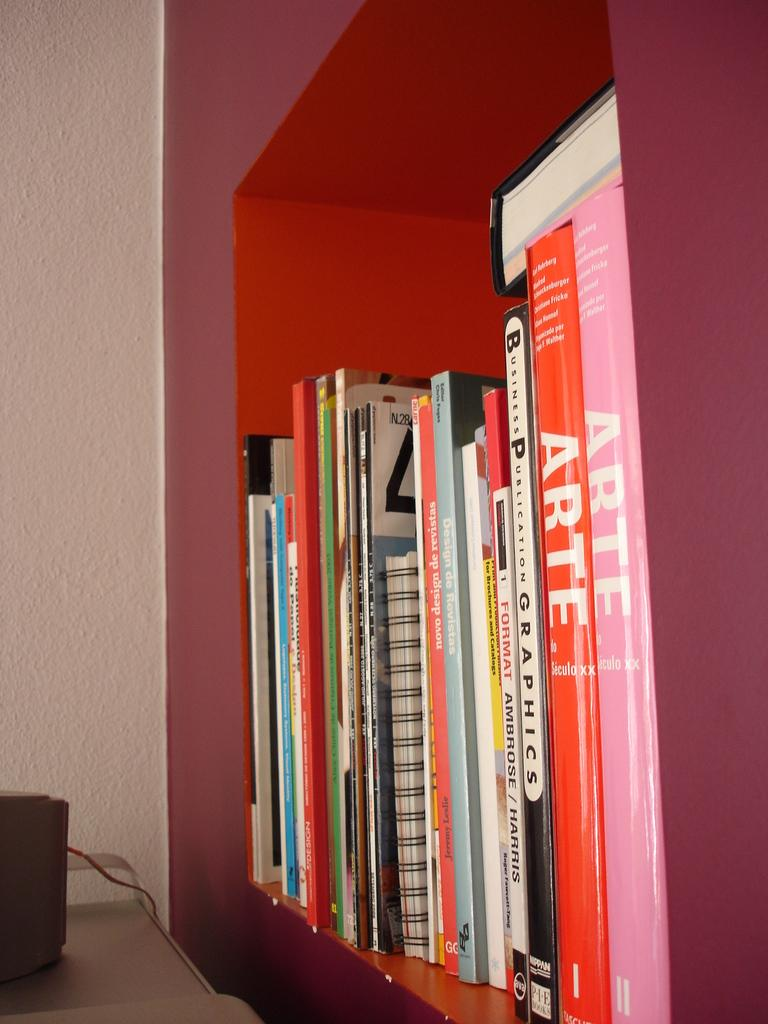<image>
Create a compact narrative representing the image presented. A pink copy of Arte sits on a shelf next to a red copy of Arte. 